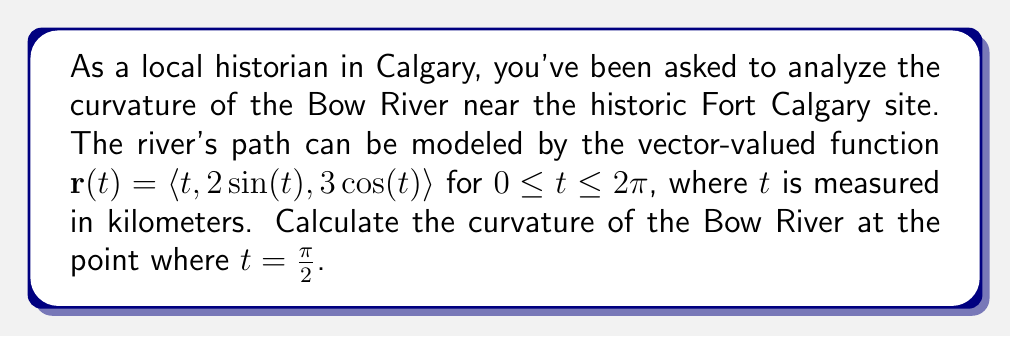Provide a solution to this math problem. To find the curvature of the Bow River at the given point, we'll use the formula for curvature of a vector-valued function:

$$\kappa = \frac{|\mathbf{r}'(t) \times \mathbf{r}''(t)|}{|\mathbf{r}'(t)|^3}$$

Let's follow these steps:

1) First, we need to find $\mathbf{r}'(t)$ and $\mathbf{r}''(t)$:

   $\mathbf{r}'(t) = \langle 1, 2\cos(t), -3\sin(t) \rangle$
   $\mathbf{r}''(t) = \langle 0, -2\sin(t), -3\cos(t) \rangle$

2) Now, let's evaluate these at $t = \frac{\pi}{2}$:

   $\mathbf{r}'(\frac{\pi}{2}) = \langle 1, 0, -3 \rangle$
   $\mathbf{r}''(\frac{\pi}{2}) = \langle 0, -2, 0 \rangle$

3) Next, we need to calculate the cross product $\mathbf{r}'(\frac{\pi}{2}) \times \mathbf{r}''(\frac{\pi}{2})$:

   $$\begin{vmatrix} 
   \mathbf{i} & \mathbf{j} & \mathbf{k} \\
   1 & 0 & -3 \\
   0 & -2 & 0
   \end{vmatrix} = \langle -6, 0, -2 \rangle$$

4) The magnitude of this cross product is:

   $|\mathbf{r}'(\frac{\pi}{2}) \times \mathbf{r}''(\frac{\pi}{2})| = \sqrt{(-6)^2 + 0^2 + (-2)^2} = \sqrt{40} = 2\sqrt{10}$

5) Now, we need $|\mathbf{r}'(\frac{\pi}{2})|^3$:

   $|\mathbf{r}'(\frac{\pi}{2})| = \sqrt{1^2 + 0^2 + (-3)^2} = \sqrt{10}$
   $|\mathbf{r}'(\frac{\pi}{2})|^3 = (\sqrt{10})^3 = 10\sqrt{10}$

6) Finally, we can calculate the curvature:

   $$\kappa = \frac{|\mathbf{r}'(\frac{\pi}{2}) \times \mathbf{r}''(\frac{\pi}{2})|}{|\mathbf{r}'(\frac{\pi}{2})|^3} = \frac{2\sqrt{10}}{10\sqrt{10}} = \frac{1}{5}$$

Therefore, the curvature of the Bow River at $t = \frac{\pi}{2}$ is $\frac{1}{5}$ km^(-1).
Answer: $\frac{1}{5}$ km^(-1) 